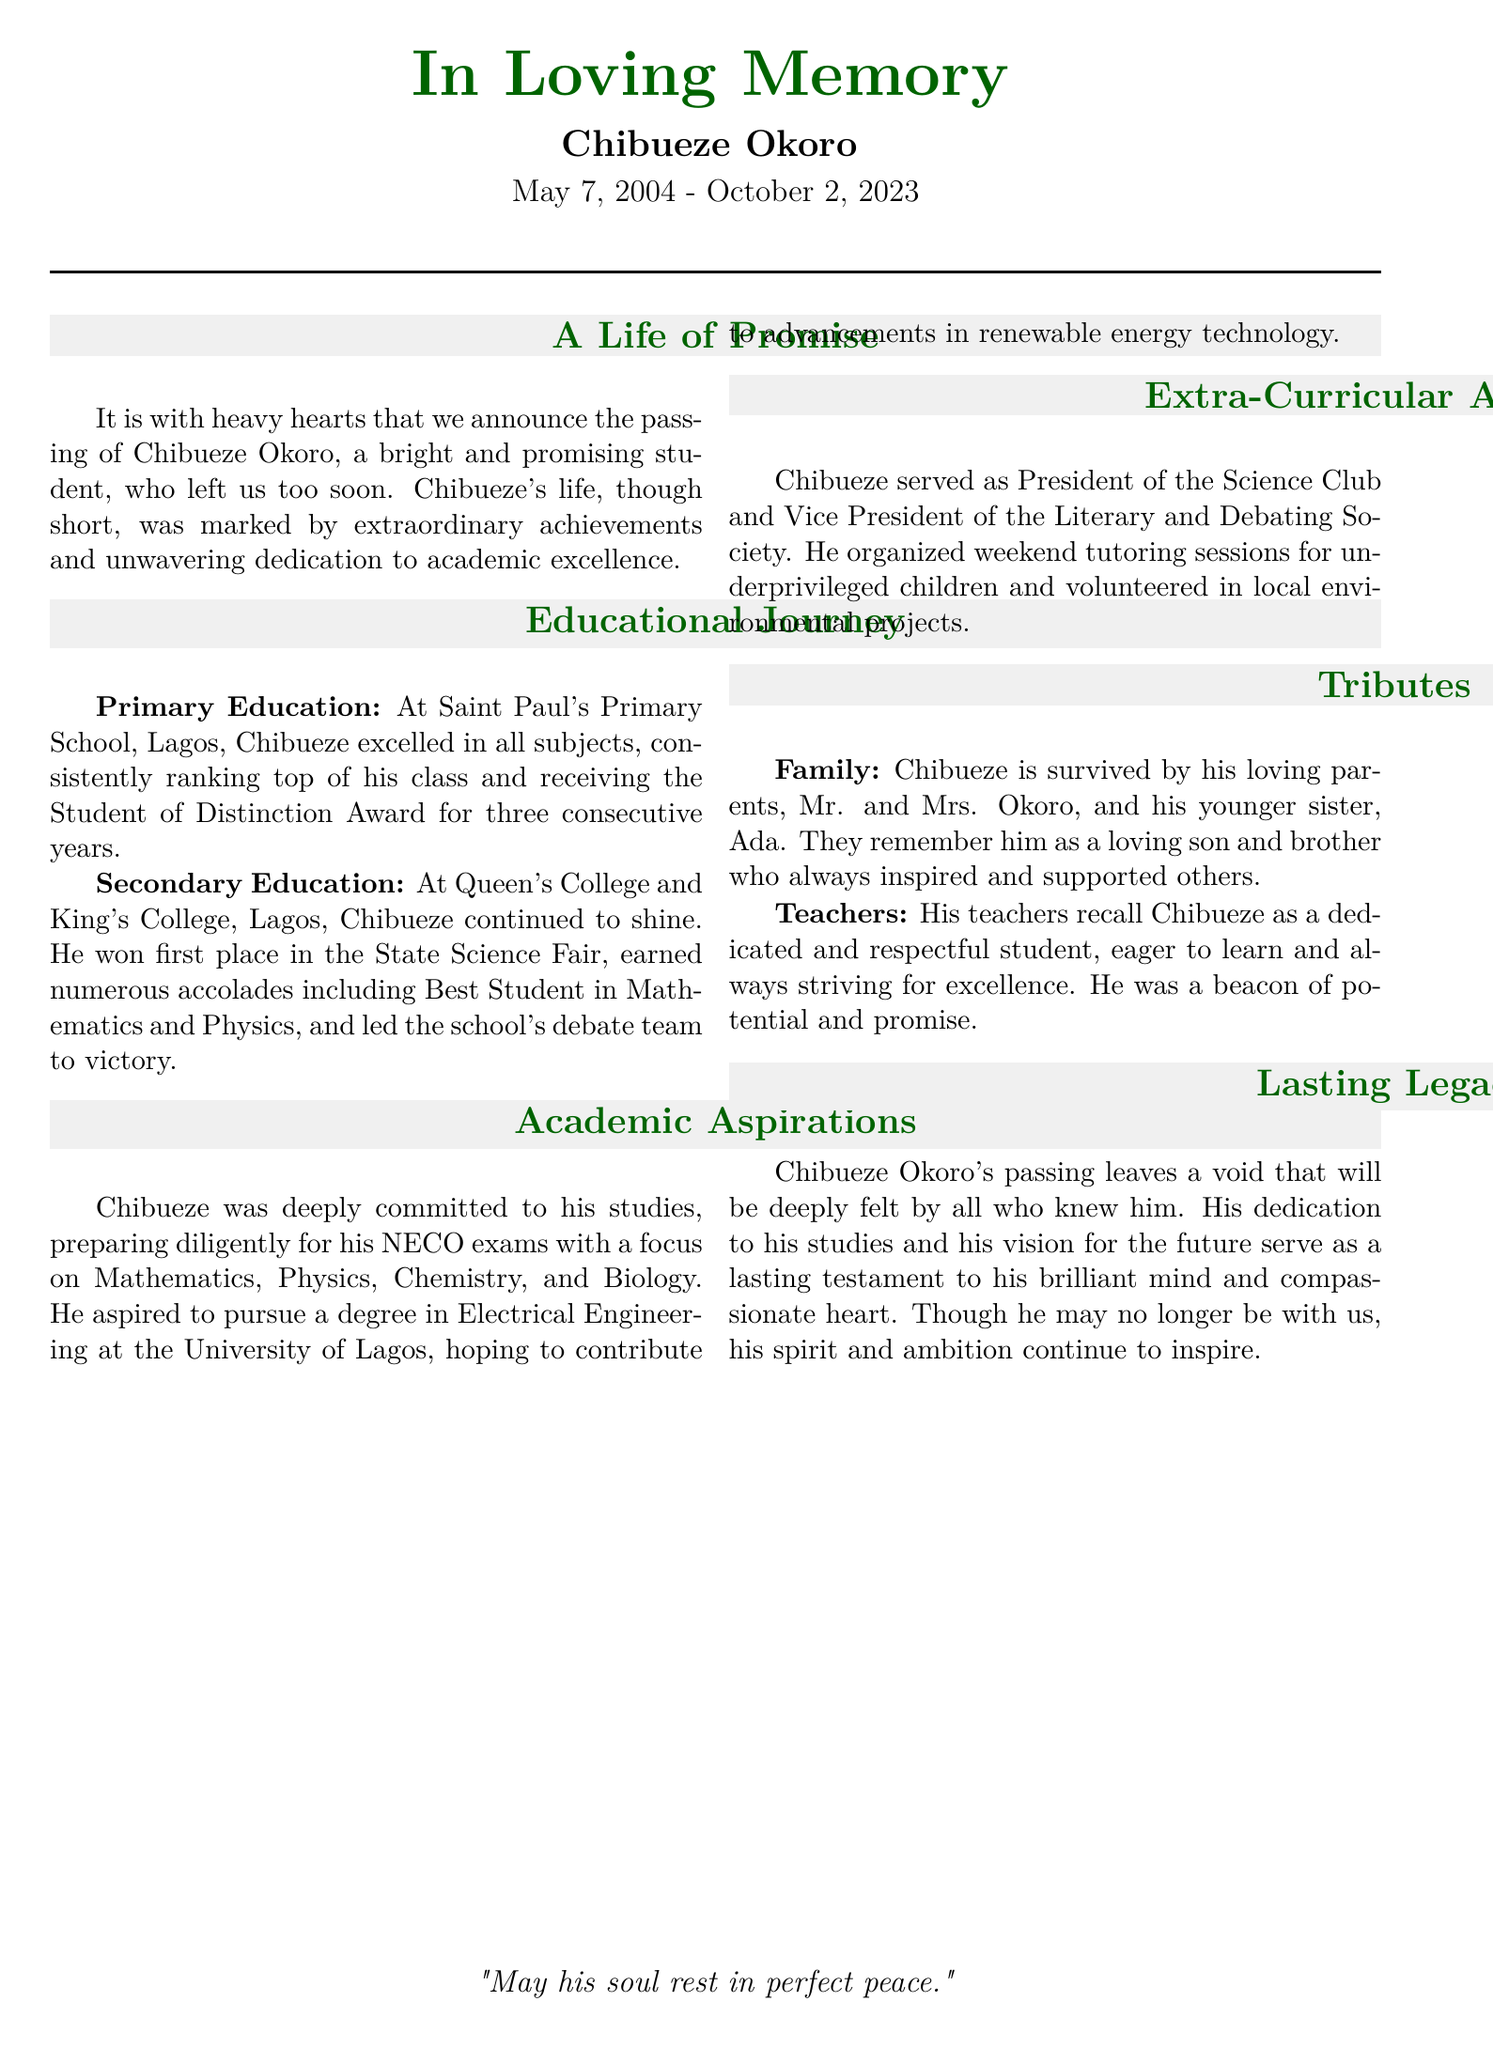What was Chibueze's date of birth? The document states that Chibueze was born on May 7, 2004.
Answer: May 7, 2004 What school did Chibueze attend for primary education? The document mentions that Chibueze attended Saint Paul's Primary School in Lagos for his primary education.
Answer: Saint Paul's Primary School Which exam was Chibueze preparing for? The document explicitly mentions that he was preparing for the NECO exams.
Answer: NECO exams What degree did Chibueze aspire to pursue? The document indicates that he aspired to pursue a degree in Electrical Engineering.
Answer: Electrical Engineering How many years did Chibueze receive the Student of Distinction Award? The document states he received the award for three consecutive years.
Answer: Three years What role did Chibueze hold in the Science Club? According to the document, Chibueze served as President of the Science Club.
Answer: President What did Chibueze's teachers remember him as? The document notes that his teachers recalled him as a dedicated and respectful student.
Answer: Dedicated and respectful What kind of projects did Chibueze volunteer for? The document mentions that he volunteered in local environmental projects.
Answer: Environmental projects 